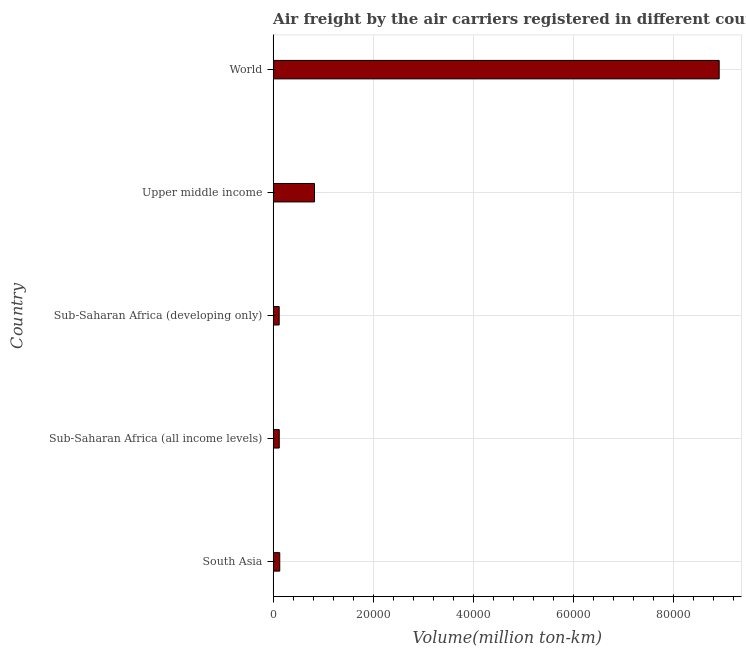Does the graph contain grids?
Give a very brief answer. Yes. What is the title of the graph?
Offer a very short reply. Air freight by the air carriers registered in different countries. What is the label or title of the X-axis?
Keep it short and to the point. Volume(million ton-km). What is the label or title of the Y-axis?
Your answer should be very brief. Country. What is the air freight in South Asia?
Offer a very short reply. 1324.7. Across all countries, what is the maximum air freight?
Give a very brief answer. 8.92e+04. Across all countries, what is the minimum air freight?
Ensure brevity in your answer.  1212.8. In which country was the air freight maximum?
Your answer should be very brief. World. In which country was the air freight minimum?
Ensure brevity in your answer.  Sub-Saharan Africa (developing only). What is the sum of the air freight?
Your answer should be very brief. 1.01e+05. What is the difference between the air freight in South Asia and Upper middle income?
Make the answer very short. -6947. What is the average air freight per country?
Make the answer very short. 2.02e+04. What is the median air freight?
Provide a succinct answer. 1324.7. In how many countries, is the air freight greater than 24000 million ton-km?
Ensure brevity in your answer.  1. What is the ratio of the air freight in South Asia to that in Upper middle income?
Your answer should be compact. 0.16. Is the difference between the air freight in South Asia and Sub-Saharan Africa (developing only) greater than the difference between any two countries?
Ensure brevity in your answer.  No. What is the difference between the highest and the second highest air freight?
Your answer should be very brief. 8.09e+04. What is the difference between the highest and the lowest air freight?
Offer a very short reply. 8.80e+04. How many bars are there?
Your response must be concise. 5. How many countries are there in the graph?
Keep it short and to the point. 5. Are the values on the major ticks of X-axis written in scientific E-notation?
Provide a succinct answer. No. What is the Volume(million ton-km) in South Asia?
Give a very brief answer. 1324.7. What is the Volume(million ton-km) of Sub-Saharan Africa (all income levels)?
Offer a terse response. 1229.6. What is the Volume(million ton-km) in Sub-Saharan Africa (developing only)?
Your answer should be compact. 1212.8. What is the Volume(million ton-km) in Upper middle income?
Give a very brief answer. 8271.7. What is the Volume(million ton-km) of World?
Ensure brevity in your answer.  8.92e+04. What is the difference between the Volume(million ton-km) in South Asia and Sub-Saharan Africa (all income levels)?
Make the answer very short. 95.1. What is the difference between the Volume(million ton-km) in South Asia and Sub-Saharan Africa (developing only)?
Your answer should be very brief. 111.9. What is the difference between the Volume(million ton-km) in South Asia and Upper middle income?
Your answer should be very brief. -6947. What is the difference between the Volume(million ton-km) in South Asia and World?
Keep it short and to the point. -8.78e+04. What is the difference between the Volume(million ton-km) in Sub-Saharan Africa (all income levels) and Upper middle income?
Offer a very short reply. -7042.1. What is the difference between the Volume(million ton-km) in Sub-Saharan Africa (all income levels) and World?
Make the answer very short. -8.79e+04. What is the difference between the Volume(million ton-km) in Sub-Saharan Africa (developing only) and Upper middle income?
Offer a very short reply. -7058.9. What is the difference between the Volume(million ton-km) in Sub-Saharan Africa (developing only) and World?
Your answer should be very brief. -8.80e+04. What is the difference between the Volume(million ton-km) in Upper middle income and World?
Offer a terse response. -8.09e+04. What is the ratio of the Volume(million ton-km) in South Asia to that in Sub-Saharan Africa (all income levels)?
Give a very brief answer. 1.08. What is the ratio of the Volume(million ton-km) in South Asia to that in Sub-Saharan Africa (developing only)?
Keep it short and to the point. 1.09. What is the ratio of the Volume(million ton-km) in South Asia to that in Upper middle income?
Your answer should be very brief. 0.16. What is the ratio of the Volume(million ton-km) in South Asia to that in World?
Provide a succinct answer. 0.01. What is the ratio of the Volume(million ton-km) in Sub-Saharan Africa (all income levels) to that in Sub-Saharan Africa (developing only)?
Give a very brief answer. 1.01. What is the ratio of the Volume(million ton-km) in Sub-Saharan Africa (all income levels) to that in Upper middle income?
Offer a very short reply. 0.15. What is the ratio of the Volume(million ton-km) in Sub-Saharan Africa (all income levels) to that in World?
Offer a terse response. 0.01. What is the ratio of the Volume(million ton-km) in Sub-Saharan Africa (developing only) to that in Upper middle income?
Your response must be concise. 0.15. What is the ratio of the Volume(million ton-km) in Sub-Saharan Africa (developing only) to that in World?
Offer a very short reply. 0.01. What is the ratio of the Volume(million ton-km) in Upper middle income to that in World?
Ensure brevity in your answer.  0.09. 